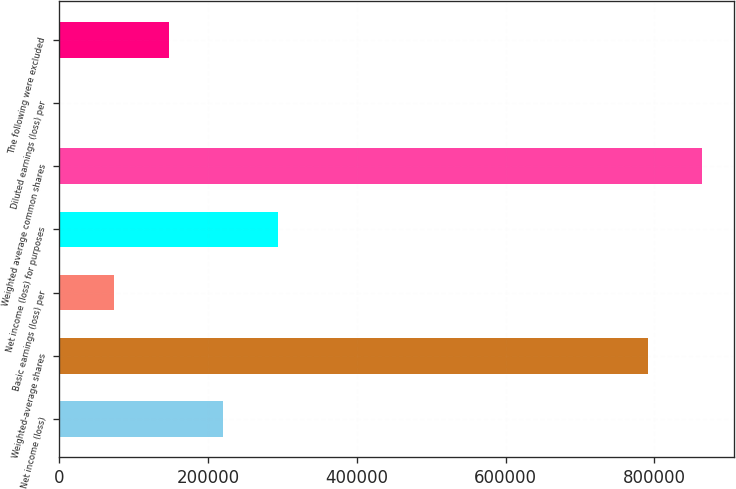Convert chart. <chart><loc_0><loc_0><loc_500><loc_500><bar_chart><fcel>Net income (loss)<fcel>Weighted-average shares<fcel>Basic earnings (loss) per<fcel>Net income (loss) for purposes<fcel>Weighted average common shares<fcel>Diluted earnings (loss) per<fcel>The following were excluded<nl><fcel>220208<fcel>790857<fcel>73405.1<fcel>293609<fcel>864258<fcel>3.93<fcel>146806<nl></chart> 